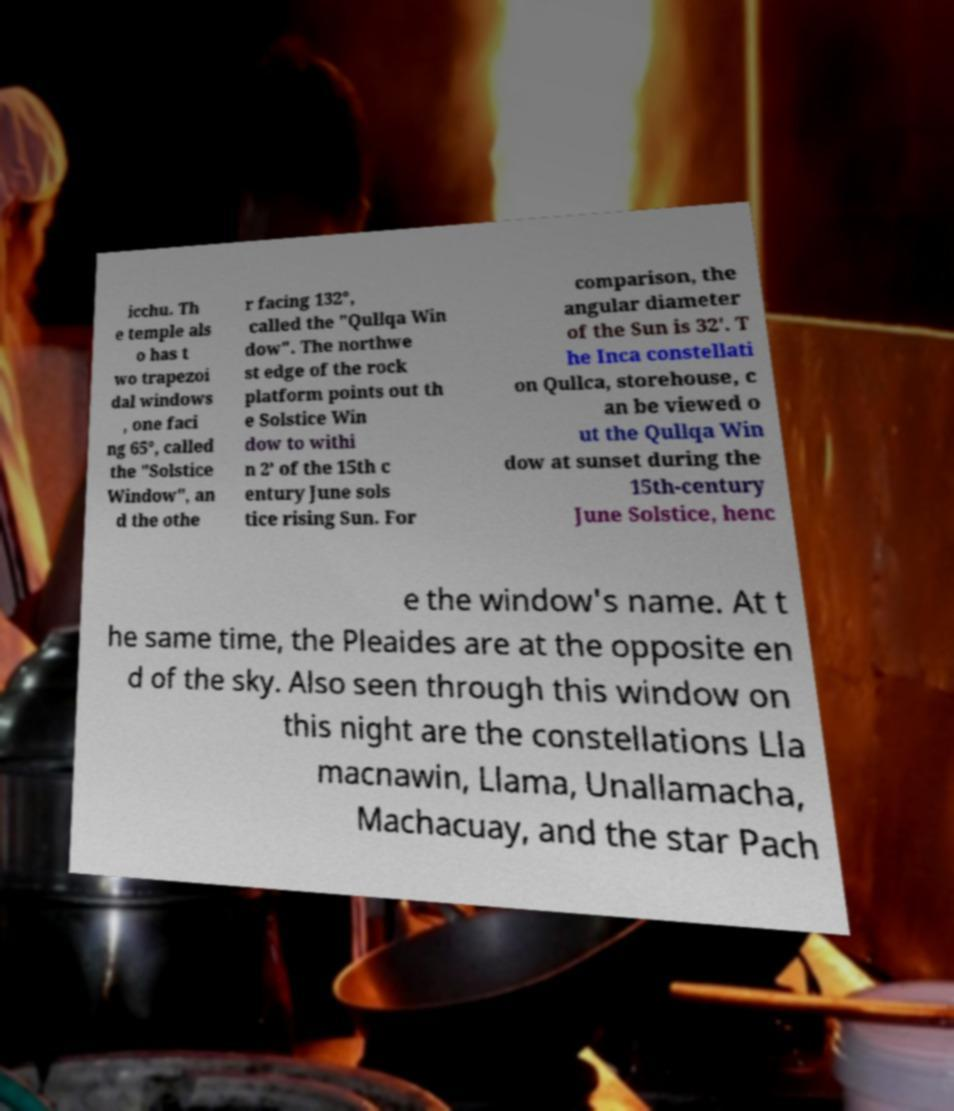Can you accurately transcribe the text from the provided image for me? icchu. Th e temple als o has t wo trapezoi dal windows , one faci ng 65°, called the "Solstice Window", an d the othe r facing 132°, called the "Qullqa Win dow". The northwe st edge of the rock platform points out th e Solstice Win dow to withi n 2’ of the 15th c entury June sols tice rising Sun. For comparison, the angular diameter of the Sun is 32'. T he Inca constellati on Qullca, storehouse, c an be viewed o ut the Qullqa Win dow at sunset during the 15th-century June Solstice, henc e the window's name. At t he same time, the Pleaides are at the opposite en d of the sky. Also seen through this window on this night are the constellations Lla macnawin, Llama, Unallamacha, Machacuay, and the star Pach 